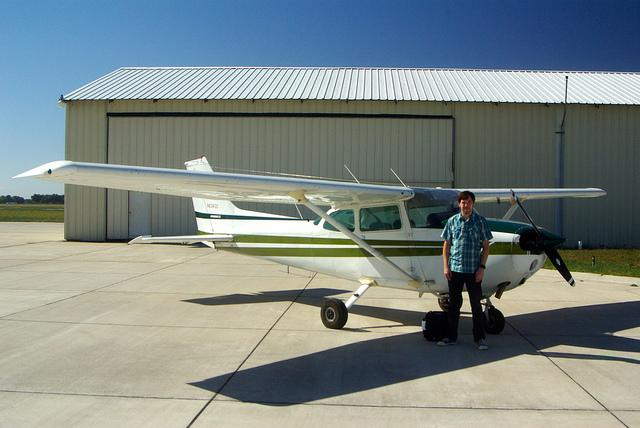Who is this person most likely to be? pilot 